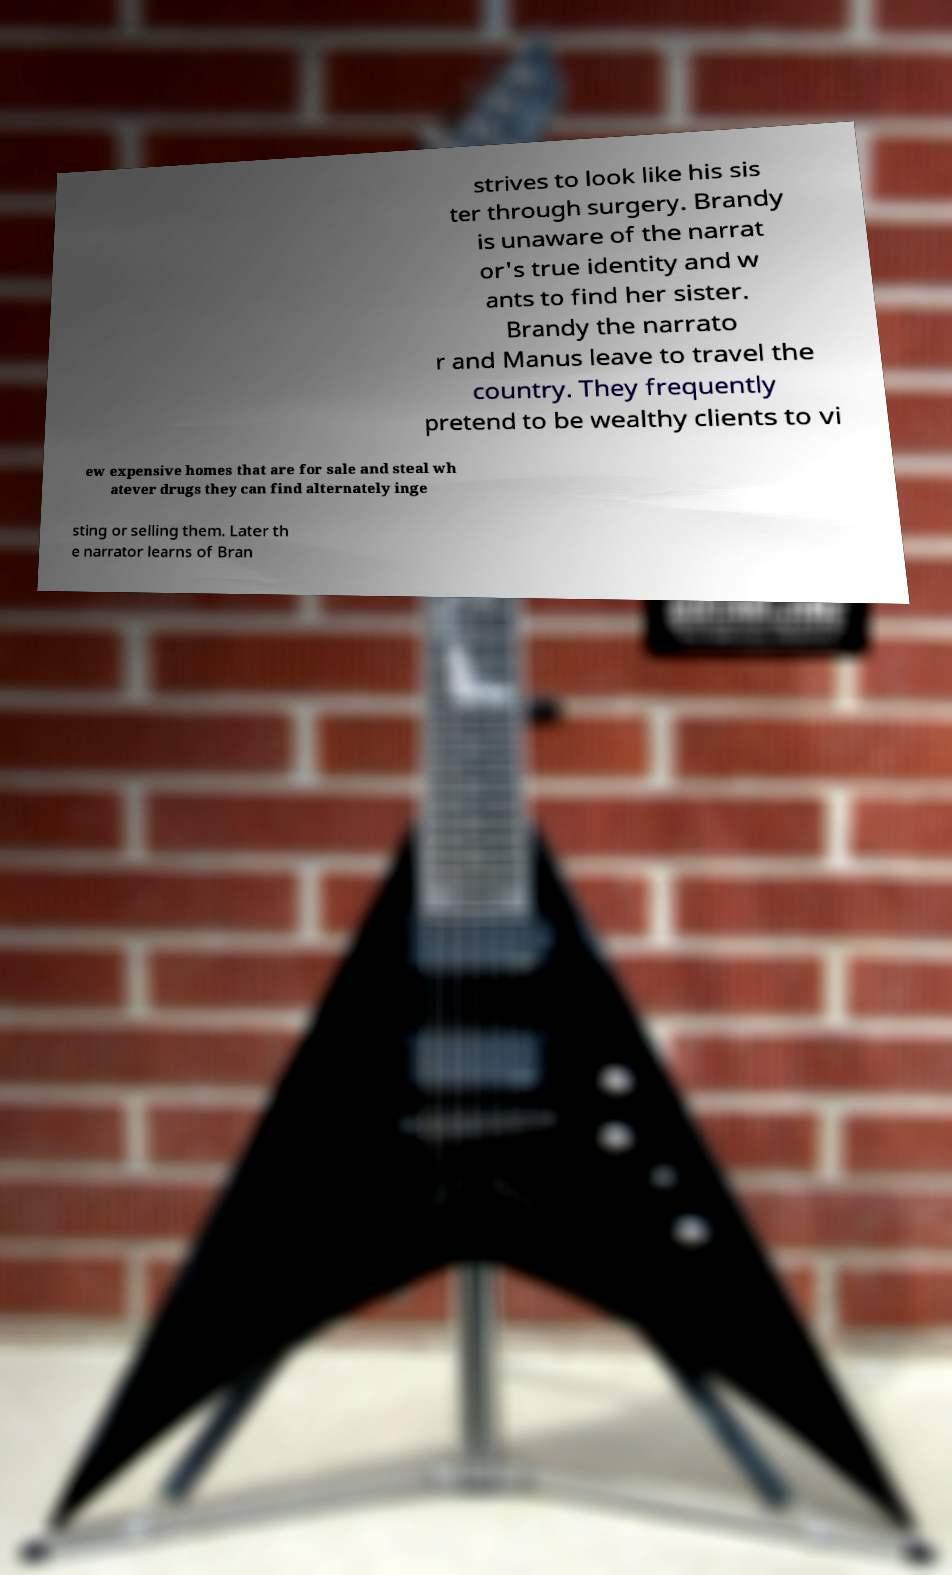Could you extract and type out the text from this image? strives to look like his sis ter through surgery. Brandy is unaware of the narrat or's true identity and w ants to find her sister. Brandy the narrato r and Manus leave to travel the country. They frequently pretend to be wealthy clients to vi ew expensive homes that are for sale and steal wh atever drugs they can find alternately inge sting or selling them. Later th e narrator learns of Bran 